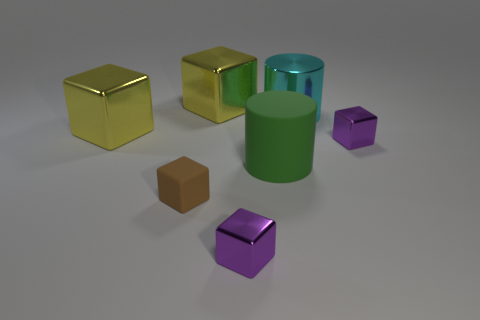Subtract all brown cubes. How many cubes are left? 4 Subtract all red blocks. Subtract all purple cylinders. How many blocks are left? 5 Add 1 purple shiny things. How many objects exist? 8 Subtract all blocks. How many objects are left? 2 Subtract 1 cyan cylinders. How many objects are left? 6 Subtract all tiny brown rubber blocks. Subtract all big metallic blocks. How many objects are left? 4 Add 6 yellow metal objects. How many yellow metal objects are left? 8 Add 2 big shiny cubes. How many big shiny cubes exist? 4 